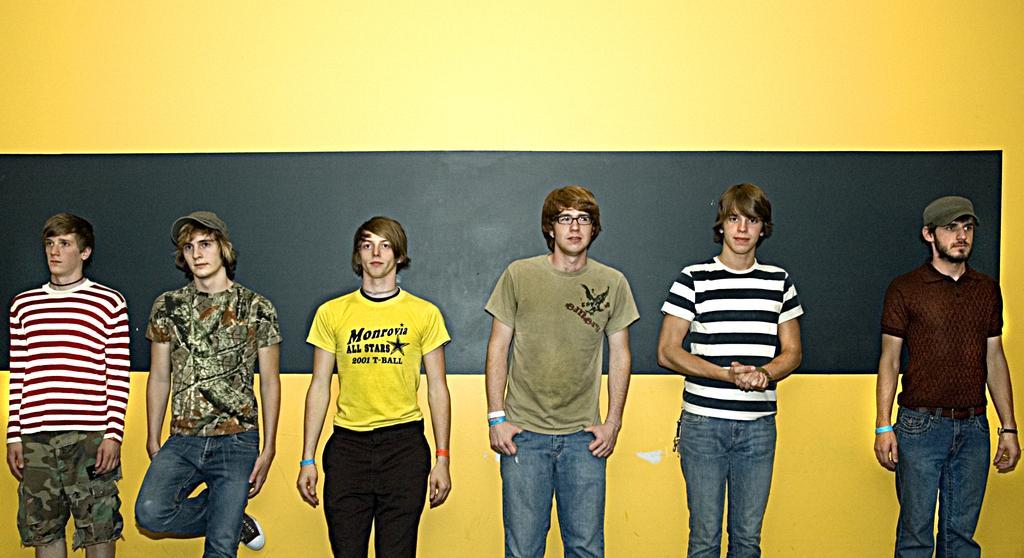Could you give a brief overview of what you see in this image? Here we can see few persons. In the background we can see a board and a yellow color wall. 